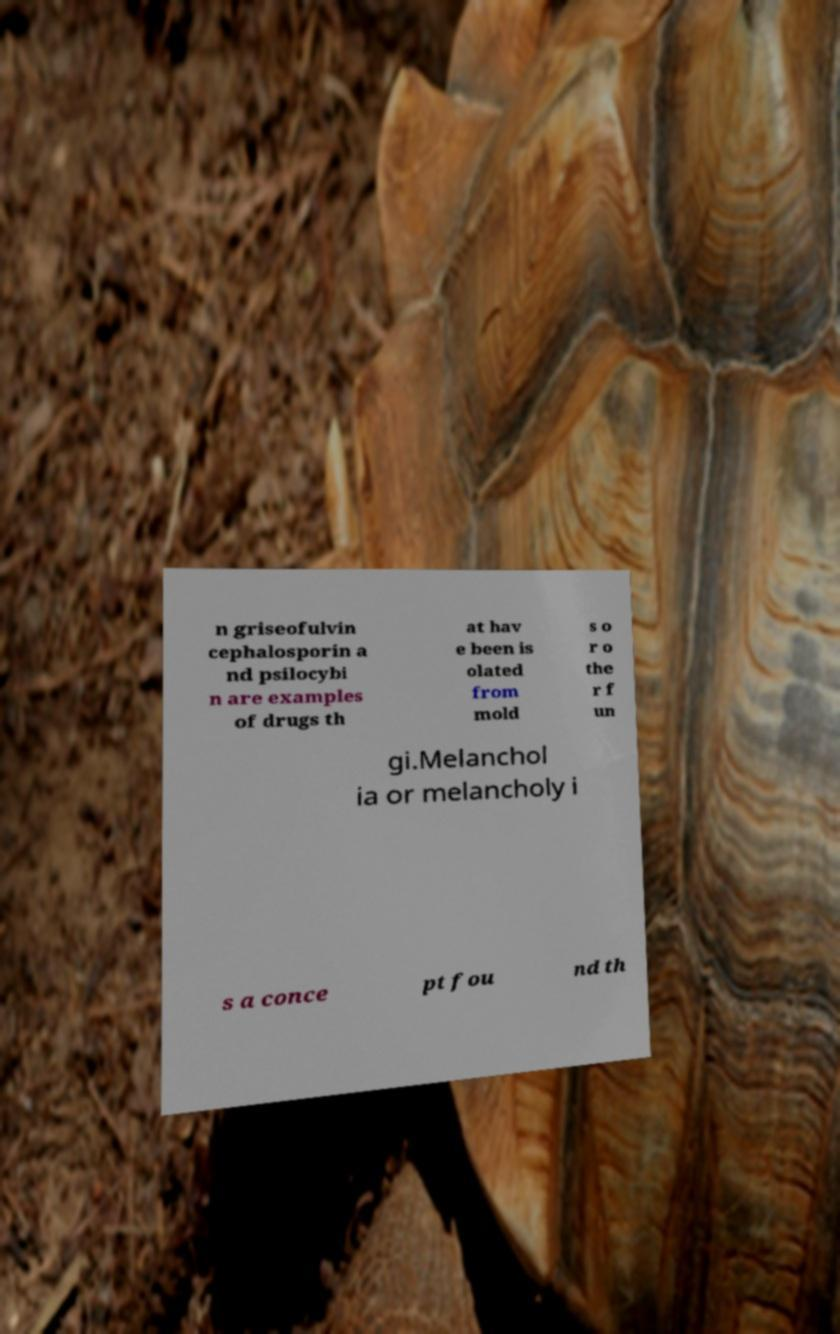Please read and relay the text visible in this image. What does it say? n griseofulvin cephalosporin a nd psilocybi n are examples of drugs th at hav e been is olated from mold s o r o the r f un gi.Melanchol ia or melancholy i s a conce pt fou nd th 